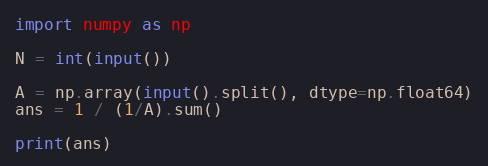<code> <loc_0><loc_0><loc_500><loc_500><_Python_>import numpy as np

N = int(input())

A = np.array(input().split(), dtype=np.float64)
ans = 1 / (1/A).sum()

print(ans)</code> 